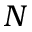<formula> <loc_0><loc_0><loc_500><loc_500>N</formula> 